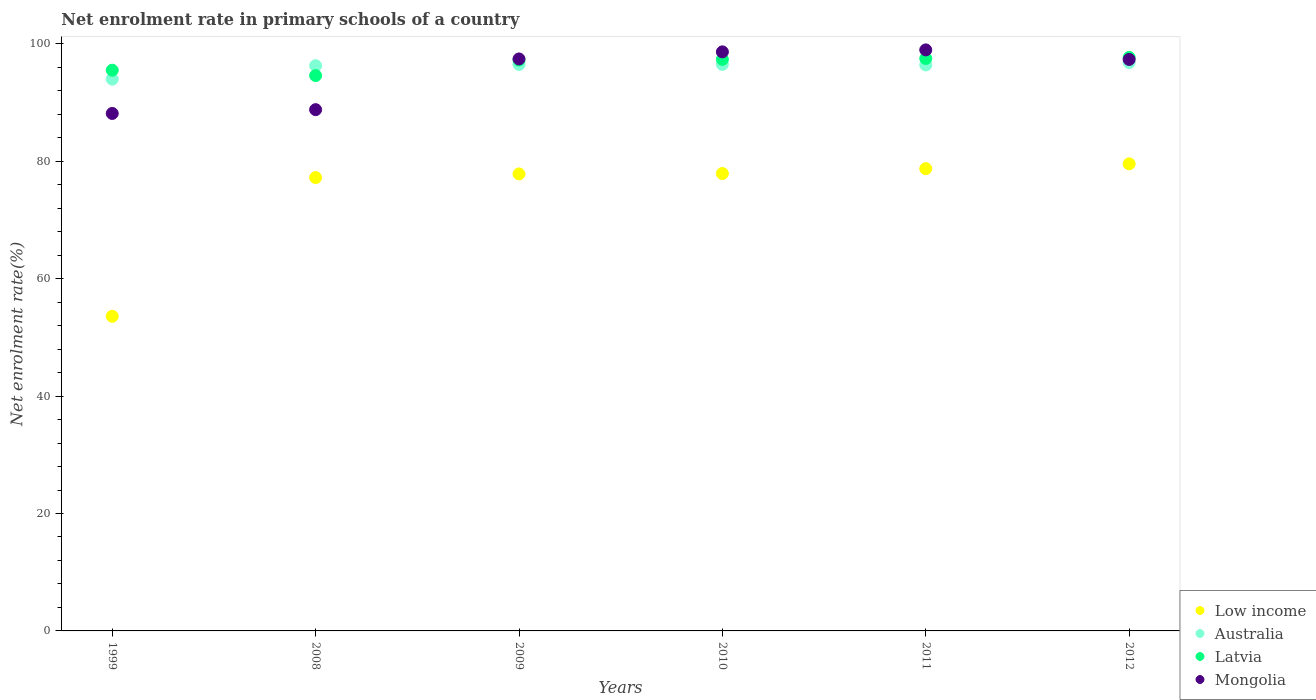How many different coloured dotlines are there?
Provide a succinct answer. 4. Is the number of dotlines equal to the number of legend labels?
Offer a very short reply. Yes. What is the net enrolment rate in primary schools in Latvia in 2010?
Provide a short and direct response. 97.35. Across all years, what is the maximum net enrolment rate in primary schools in Latvia?
Give a very brief answer. 97.68. Across all years, what is the minimum net enrolment rate in primary schools in Low income?
Your answer should be compact. 53.58. What is the total net enrolment rate in primary schools in Mongolia in the graph?
Give a very brief answer. 569.25. What is the difference between the net enrolment rate in primary schools in Mongolia in 2008 and that in 2011?
Keep it short and to the point. -10.18. What is the difference between the net enrolment rate in primary schools in Australia in 1999 and the net enrolment rate in primary schools in Low income in 2009?
Provide a short and direct response. 16.14. What is the average net enrolment rate in primary schools in Mongolia per year?
Ensure brevity in your answer.  94.87. In the year 2009, what is the difference between the net enrolment rate in primary schools in Low income and net enrolment rate in primary schools in Australia?
Offer a terse response. -18.65. What is the ratio of the net enrolment rate in primary schools in Mongolia in 2010 to that in 2011?
Provide a short and direct response. 1. Is the net enrolment rate in primary schools in Mongolia in 1999 less than that in 2009?
Provide a short and direct response. Yes. What is the difference between the highest and the second highest net enrolment rate in primary schools in Low income?
Provide a succinct answer. 0.82. What is the difference between the highest and the lowest net enrolment rate in primary schools in Australia?
Make the answer very short. 2.84. Is the sum of the net enrolment rate in primary schools in Low income in 1999 and 2011 greater than the maximum net enrolment rate in primary schools in Mongolia across all years?
Provide a succinct answer. Yes. Does the net enrolment rate in primary schools in Mongolia monotonically increase over the years?
Offer a terse response. No. Is the net enrolment rate in primary schools in Latvia strictly less than the net enrolment rate in primary schools in Low income over the years?
Make the answer very short. No. Are the values on the major ticks of Y-axis written in scientific E-notation?
Ensure brevity in your answer.  No. Does the graph contain grids?
Keep it short and to the point. No. How many legend labels are there?
Your response must be concise. 4. What is the title of the graph?
Your response must be concise. Net enrolment rate in primary schools of a country. What is the label or title of the Y-axis?
Provide a succinct answer. Net enrolment rate(%). What is the Net enrolment rate(%) in Low income in 1999?
Ensure brevity in your answer.  53.58. What is the Net enrolment rate(%) of Australia in 1999?
Offer a very short reply. 93.98. What is the Net enrolment rate(%) in Latvia in 1999?
Provide a succinct answer. 95.5. What is the Net enrolment rate(%) of Mongolia in 1999?
Your response must be concise. 88.13. What is the Net enrolment rate(%) in Low income in 2008?
Your answer should be compact. 77.21. What is the Net enrolment rate(%) of Australia in 2008?
Provide a succinct answer. 96.27. What is the Net enrolment rate(%) of Latvia in 2008?
Offer a terse response. 94.59. What is the Net enrolment rate(%) in Mongolia in 2008?
Give a very brief answer. 88.78. What is the Net enrolment rate(%) in Low income in 2009?
Ensure brevity in your answer.  77.84. What is the Net enrolment rate(%) of Australia in 2009?
Provide a short and direct response. 96.49. What is the Net enrolment rate(%) in Latvia in 2009?
Provide a short and direct response. 97.23. What is the Net enrolment rate(%) in Mongolia in 2009?
Provide a short and direct response. 97.42. What is the Net enrolment rate(%) of Low income in 2010?
Ensure brevity in your answer.  77.9. What is the Net enrolment rate(%) of Australia in 2010?
Your response must be concise. 96.49. What is the Net enrolment rate(%) of Latvia in 2010?
Your answer should be compact. 97.35. What is the Net enrolment rate(%) of Mongolia in 2010?
Your answer should be very brief. 98.62. What is the Net enrolment rate(%) in Low income in 2011?
Keep it short and to the point. 78.74. What is the Net enrolment rate(%) in Australia in 2011?
Provide a succinct answer. 96.4. What is the Net enrolment rate(%) of Latvia in 2011?
Your answer should be very brief. 97.49. What is the Net enrolment rate(%) in Mongolia in 2011?
Your answer should be very brief. 98.96. What is the Net enrolment rate(%) of Low income in 2012?
Make the answer very short. 79.55. What is the Net enrolment rate(%) in Australia in 2012?
Your answer should be compact. 96.82. What is the Net enrolment rate(%) of Latvia in 2012?
Provide a succinct answer. 97.68. What is the Net enrolment rate(%) of Mongolia in 2012?
Your answer should be very brief. 97.33. Across all years, what is the maximum Net enrolment rate(%) in Low income?
Provide a short and direct response. 79.55. Across all years, what is the maximum Net enrolment rate(%) in Australia?
Keep it short and to the point. 96.82. Across all years, what is the maximum Net enrolment rate(%) of Latvia?
Provide a succinct answer. 97.68. Across all years, what is the maximum Net enrolment rate(%) in Mongolia?
Provide a short and direct response. 98.96. Across all years, what is the minimum Net enrolment rate(%) in Low income?
Offer a very short reply. 53.58. Across all years, what is the minimum Net enrolment rate(%) in Australia?
Give a very brief answer. 93.98. Across all years, what is the minimum Net enrolment rate(%) of Latvia?
Provide a short and direct response. 94.59. Across all years, what is the minimum Net enrolment rate(%) of Mongolia?
Your answer should be very brief. 88.13. What is the total Net enrolment rate(%) in Low income in the graph?
Your answer should be very brief. 444.82. What is the total Net enrolment rate(%) of Australia in the graph?
Offer a terse response. 576.44. What is the total Net enrolment rate(%) of Latvia in the graph?
Your response must be concise. 579.83. What is the total Net enrolment rate(%) in Mongolia in the graph?
Ensure brevity in your answer.  569.25. What is the difference between the Net enrolment rate(%) of Low income in 1999 and that in 2008?
Offer a terse response. -23.63. What is the difference between the Net enrolment rate(%) in Australia in 1999 and that in 2008?
Make the answer very short. -2.29. What is the difference between the Net enrolment rate(%) in Latvia in 1999 and that in 2008?
Offer a very short reply. 0.91. What is the difference between the Net enrolment rate(%) of Mongolia in 1999 and that in 2008?
Provide a succinct answer. -0.65. What is the difference between the Net enrolment rate(%) in Low income in 1999 and that in 2009?
Offer a terse response. -24.25. What is the difference between the Net enrolment rate(%) in Australia in 1999 and that in 2009?
Your response must be concise. -2.51. What is the difference between the Net enrolment rate(%) in Latvia in 1999 and that in 2009?
Offer a terse response. -1.73. What is the difference between the Net enrolment rate(%) in Mongolia in 1999 and that in 2009?
Your answer should be compact. -9.28. What is the difference between the Net enrolment rate(%) of Low income in 1999 and that in 2010?
Provide a succinct answer. -24.32. What is the difference between the Net enrolment rate(%) of Australia in 1999 and that in 2010?
Provide a short and direct response. -2.51. What is the difference between the Net enrolment rate(%) in Latvia in 1999 and that in 2010?
Give a very brief answer. -1.85. What is the difference between the Net enrolment rate(%) in Mongolia in 1999 and that in 2010?
Provide a succinct answer. -10.49. What is the difference between the Net enrolment rate(%) of Low income in 1999 and that in 2011?
Keep it short and to the point. -25.15. What is the difference between the Net enrolment rate(%) of Australia in 1999 and that in 2011?
Keep it short and to the point. -2.42. What is the difference between the Net enrolment rate(%) in Latvia in 1999 and that in 2011?
Keep it short and to the point. -1.99. What is the difference between the Net enrolment rate(%) in Mongolia in 1999 and that in 2011?
Offer a terse response. -10.83. What is the difference between the Net enrolment rate(%) in Low income in 1999 and that in 2012?
Provide a short and direct response. -25.97. What is the difference between the Net enrolment rate(%) of Australia in 1999 and that in 2012?
Your answer should be compact. -2.84. What is the difference between the Net enrolment rate(%) of Latvia in 1999 and that in 2012?
Ensure brevity in your answer.  -2.18. What is the difference between the Net enrolment rate(%) of Mongolia in 1999 and that in 2012?
Make the answer very short. -9.2. What is the difference between the Net enrolment rate(%) of Low income in 2008 and that in 2009?
Your response must be concise. -0.63. What is the difference between the Net enrolment rate(%) in Australia in 2008 and that in 2009?
Your response must be concise. -0.21. What is the difference between the Net enrolment rate(%) of Latvia in 2008 and that in 2009?
Offer a terse response. -2.64. What is the difference between the Net enrolment rate(%) in Mongolia in 2008 and that in 2009?
Make the answer very short. -8.64. What is the difference between the Net enrolment rate(%) of Low income in 2008 and that in 2010?
Provide a succinct answer. -0.69. What is the difference between the Net enrolment rate(%) of Australia in 2008 and that in 2010?
Keep it short and to the point. -0.22. What is the difference between the Net enrolment rate(%) of Latvia in 2008 and that in 2010?
Offer a very short reply. -2.76. What is the difference between the Net enrolment rate(%) of Mongolia in 2008 and that in 2010?
Provide a succinct answer. -9.84. What is the difference between the Net enrolment rate(%) of Low income in 2008 and that in 2011?
Make the answer very short. -1.53. What is the difference between the Net enrolment rate(%) in Australia in 2008 and that in 2011?
Offer a very short reply. -0.12. What is the difference between the Net enrolment rate(%) in Latvia in 2008 and that in 2011?
Your answer should be very brief. -2.91. What is the difference between the Net enrolment rate(%) of Mongolia in 2008 and that in 2011?
Offer a very short reply. -10.18. What is the difference between the Net enrolment rate(%) of Low income in 2008 and that in 2012?
Ensure brevity in your answer.  -2.34. What is the difference between the Net enrolment rate(%) of Australia in 2008 and that in 2012?
Your answer should be compact. -0.55. What is the difference between the Net enrolment rate(%) of Latvia in 2008 and that in 2012?
Keep it short and to the point. -3.09. What is the difference between the Net enrolment rate(%) of Mongolia in 2008 and that in 2012?
Offer a very short reply. -8.55. What is the difference between the Net enrolment rate(%) in Low income in 2009 and that in 2010?
Ensure brevity in your answer.  -0.07. What is the difference between the Net enrolment rate(%) in Australia in 2009 and that in 2010?
Ensure brevity in your answer.  -0.01. What is the difference between the Net enrolment rate(%) of Latvia in 2009 and that in 2010?
Offer a very short reply. -0.12. What is the difference between the Net enrolment rate(%) of Mongolia in 2009 and that in 2010?
Provide a succinct answer. -1.2. What is the difference between the Net enrolment rate(%) of Low income in 2009 and that in 2011?
Offer a terse response. -0.9. What is the difference between the Net enrolment rate(%) in Australia in 2009 and that in 2011?
Provide a short and direct response. 0.09. What is the difference between the Net enrolment rate(%) of Latvia in 2009 and that in 2011?
Offer a terse response. -0.27. What is the difference between the Net enrolment rate(%) of Mongolia in 2009 and that in 2011?
Provide a succinct answer. -1.54. What is the difference between the Net enrolment rate(%) of Low income in 2009 and that in 2012?
Your answer should be compact. -1.72. What is the difference between the Net enrolment rate(%) in Australia in 2009 and that in 2012?
Your response must be concise. -0.34. What is the difference between the Net enrolment rate(%) in Latvia in 2009 and that in 2012?
Make the answer very short. -0.45. What is the difference between the Net enrolment rate(%) of Mongolia in 2009 and that in 2012?
Provide a short and direct response. 0.08. What is the difference between the Net enrolment rate(%) of Low income in 2010 and that in 2011?
Your answer should be compact. -0.83. What is the difference between the Net enrolment rate(%) of Australia in 2010 and that in 2011?
Give a very brief answer. 0.1. What is the difference between the Net enrolment rate(%) in Latvia in 2010 and that in 2011?
Keep it short and to the point. -0.15. What is the difference between the Net enrolment rate(%) of Mongolia in 2010 and that in 2011?
Your answer should be compact. -0.34. What is the difference between the Net enrolment rate(%) in Low income in 2010 and that in 2012?
Ensure brevity in your answer.  -1.65. What is the difference between the Net enrolment rate(%) of Australia in 2010 and that in 2012?
Provide a succinct answer. -0.33. What is the difference between the Net enrolment rate(%) in Latvia in 2010 and that in 2012?
Keep it short and to the point. -0.33. What is the difference between the Net enrolment rate(%) in Mongolia in 2010 and that in 2012?
Your answer should be very brief. 1.29. What is the difference between the Net enrolment rate(%) in Low income in 2011 and that in 2012?
Give a very brief answer. -0.82. What is the difference between the Net enrolment rate(%) in Australia in 2011 and that in 2012?
Your answer should be compact. -0.43. What is the difference between the Net enrolment rate(%) in Latvia in 2011 and that in 2012?
Provide a succinct answer. -0.18. What is the difference between the Net enrolment rate(%) in Mongolia in 2011 and that in 2012?
Provide a succinct answer. 1.63. What is the difference between the Net enrolment rate(%) in Low income in 1999 and the Net enrolment rate(%) in Australia in 2008?
Keep it short and to the point. -42.69. What is the difference between the Net enrolment rate(%) in Low income in 1999 and the Net enrolment rate(%) in Latvia in 2008?
Give a very brief answer. -41.01. What is the difference between the Net enrolment rate(%) of Low income in 1999 and the Net enrolment rate(%) of Mongolia in 2008?
Offer a terse response. -35.2. What is the difference between the Net enrolment rate(%) of Australia in 1999 and the Net enrolment rate(%) of Latvia in 2008?
Keep it short and to the point. -0.61. What is the difference between the Net enrolment rate(%) of Australia in 1999 and the Net enrolment rate(%) of Mongolia in 2008?
Offer a terse response. 5.2. What is the difference between the Net enrolment rate(%) of Latvia in 1999 and the Net enrolment rate(%) of Mongolia in 2008?
Provide a succinct answer. 6.72. What is the difference between the Net enrolment rate(%) in Low income in 1999 and the Net enrolment rate(%) in Australia in 2009?
Provide a short and direct response. -42.9. What is the difference between the Net enrolment rate(%) of Low income in 1999 and the Net enrolment rate(%) of Latvia in 2009?
Offer a very short reply. -43.64. What is the difference between the Net enrolment rate(%) in Low income in 1999 and the Net enrolment rate(%) in Mongolia in 2009?
Keep it short and to the point. -43.84. What is the difference between the Net enrolment rate(%) of Australia in 1999 and the Net enrolment rate(%) of Latvia in 2009?
Provide a succinct answer. -3.25. What is the difference between the Net enrolment rate(%) of Australia in 1999 and the Net enrolment rate(%) of Mongolia in 2009?
Ensure brevity in your answer.  -3.44. What is the difference between the Net enrolment rate(%) of Latvia in 1999 and the Net enrolment rate(%) of Mongolia in 2009?
Give a very brief answer. -1.92. What is the difference between the Net enrolment rate(%) of Low income in 1999 and the Net enrolment rate(%) of Australia in 2010?
Give a very brief answer. -42.91. What is the difference between the Net enrolment rate(%) in Low income in 1999 and the Net enrolment rate(%) in Latvia in 2010?
Ensure brevity in your answer.  -43.76. What is the difference between the Net enrolment rate(%) in Low income in 1999 and the Net enrolment rate(%) in Mongolia in 2010?
Offer a terse response. -45.04. What is the difference between the Net enrolment rate(%) of Australia in 1999 and the Net enrolment rate(%) of Latvia in 2010?
Your answer should be compact. -3.37. What is the difference between the Net enrolment rate(%) in Australia in 1999 and the Net enrolment rate(%) in Mongolia in 2010?
Keep it short and to the point. -4.65. What is the difference between the Net enrolment rate(%) of Latvia in 1999 and the Net enrolment rate(%) of Mongolia in 2010?
Keep it short and to the point. -3.12. What is the difference between the Net enrolment rate(%) of Low income in 1999 and the Net enrolment rate(%) of Australia in 2011?
Keep it short and to the point. -42.81. What is the difference between the Net enrolment rate(%) in Low income in 1999 and the Net enrolment rate(%) in Latvia in 2011?
Ensure brevity in your answer.  -43.91. What is the difference between the Net enrolment rate(%) of Low income in 1999 and the Net enrolment rate(%) of Mongolia in 2011?
Provide a short and direct response. -45.38. What is the difference between the Net enrolment rate(%) in Australia in 1999 and the Net enrolment rate(%) in Latvia in 2011?
Make the answer very short. -3.52. What is the difference between the Net enrolment rate(%) in Australia in 1999 and the Net enrolment rate(%) in Mongolia in 2011?
Your answer should be compact. -4.98. What is the difference between the Net enrolment rate(%) of Latvia in 1999 and the Net enrolment rate(%) of Mongolia in 2011?
Provide a succinct answer. -3.46. What is the difference between the Net enrolment rate(%) of Low income in 1999 and the Net enrolment rate(%) of Australia in 2012?
Your answer should be very brief. -43.24. What is the difference between the Net enrolment rate(%) in Low income in 1999 and the Net enrolment rate(%) in Latvia in 2012?
Provide a short and direct response. -44.1. What is the difference between the Net enrolment rate(%) of Low income in 1999 and the Net enrolment rate(%) of Mongolia in 2012?
Ensure brevity in your answer.  -43.75. What is the difference between the Net enrolment rate(%) of Australia in 1999 and the Net enrolment rate(%) of Latvia in 2012?
Provide a short and direct response. -3.7. What is the difference between the Net enrolment rate(%) of Australia in 1999 and the Net enrolment rate(%) of Mongolia in 2012?
Make the answer very short. -3.36. What is the difference between the Net enrolment rate(%) in Latvia in 1999 and the Net enrolment rate(%) in Mongolia in 2012?
Your response must be concise. -1.83. What is the difference between the Net enrolment rate(%) in Low income in 2008 and the Net enrolment rate(%) in Australia in 2009?
Provide a succinct answer. -19.28. What is the difference between the Net enrolment rate(%) in Low income in 2008 and the Net enrolment rate(%) in Latvia in 2009?
Your answer should be compact. -20.02. What is the difference between the Net enrolment rate(%) of Low income in 2008 and the Net enrolment rate(%) of Mongolia in 2009?
Ensure brevity in your answer.  -20.21. What is the difference between the Net enrolment rate(%) of Australia in 2008 and the Net enrolment rate(%) of Latvia in 2009?
Offer a very short reply. -0.95. What is the difference between the Net enrolment rate(%) in Australia in 2008 and the Net enrolment rate(%) in Mongolia in 2009?
Offer a terse response. -1.15. What is the difference between the Net enrolment rate(%) in Latvia in 2008 and the Net enrolment rate(%) in Mongolia in 2009?
Offer a very short reply. -2.83. What is the difference between the Net enrolment rate(%) of Low income in 2008 and the Net enrolment rate(%) of Australia in 2010?
Your answer should be compact. -19.28. What is the difference between the Net enrolment rate(%) in Low income in 2008 and the Net enrolment rate(%) in Latvia in 2010?
Provide a succinct answer. -20.14. What is the difference between the Net enrolment rate(%) in Low income in 2008 and the Net enrolment rate(%) in Mongolia in 2010?
Make the answer very short. -21.41. What is the difference between the Net enrolment rate(%) in Australia in 2008 and the Net enrolment rate(%) in Latvia in 2010?
Your answer should be very brief. -1.08. What is the difference between the Net enrolment rate(%) of Australia in 2008 and the Net enrolment rate(%) of Mongolia in 2010?
Ensure brevity in your answer.  -2.35. What is the difference between the Net enrolment rate(%) in Latvia in 2008 and the Net enrolment rate(%) in Mongolia in 2010?
Your answer should be very brief. -4.03. What is the difference between the Net enrolment rate(%) of Low income in 2008 and the Net enrolment rate(%) of Australia in 2011?
Your response must be concise. -19.19. What is the difference between the Net enrolment rate(%) in Low income in 2008 and the Net enrolment rate(%) in Latvia in 2011?
Your response must be concise. -20.28. What is the difference between the Net enrolment rate(%) in Low income in 2008 and the Net enrolment rate(%) in Mongolia in 2011?
Provide a succinct answer. -21.75. What is the difference between the Net enrolment rate(%) in Australia in 2008 and the Net enrolment rate(%) in Latvia in 2011?
Give a very brief answer. -1.22. What is the difference between the Net enrolment rate(%) of Australia in 2008 and the Net enrolment rate(%) of Mongolia in 2011?
Make the answer very short. -2.69. What is the difference between the Net enrolment rate(%) of Latvia in 2008 and the Net enrolment rate(%) of Mongolia in 2011?
Give a very brief answer. -4.37. What is the difference between the Net enrolment rate(%) in Low income in 2008 and the Net enrolment rate(%) in Australia in 2012?
Your response must be concise. -19.61. What is the difference between the Net enrolment rate(%) of Low income in 2008 and the Net enrolment rate(%) of Latvia in 2012?
Provide a short and direct response. -20.47. What is the difference between the Net enrolment rate(%) of Low income in 2008 and the Net enrolment rate(%) of Mongolia in 2012?
Provide a succinct answer. -20.12. What is the difference between the Net enrolment rate(%) in Australia in 2008 and the Net enrolment rate(%) in Latvia in 2012?
Offer a very short reply. -1.41. What is the difference between the Net enrolment rate(%) of Australia in 2008 and the Net enrolment rate(%) of Mongolia in 2012?
Give a very brief answer. -1.06. What is the difference between the Net enrolment rate(%) in Latvia in 2008 and the Net enrolment rate(%) in Mongolia in 2012?
Give a very brief answer. -2.75. What is the difference between the Net enrolment rate(%) in Low income in 2009 and the Net enrolment rate(%) in Australia in 2010?
Keep it short and to the point. -18.66. What is the difference between the Net enrolment rate(%) in Low income in 2009 and the Net enrolment rate(%) in Latvia in 2010?
Make the answer very short. -19.51. What is the difference between the Net enrolment rate(%) of Low income in 2009 and the Net enrolment rate(%) of Mongolia in 2010?
Offer a terse response. -20.79. What is the difference between the Net enrolment rate(%) of Australia in 2009 and the Net enrolment rate(%) of Latvia in 2010?
Offer a terse response. -0.86. What is the difference between the Net enrolment rate(%) in Australia in 2009 and the Net enrolment rate(%) in Mongolia in 2010?
Provide a short and direct response. -2.14. What is the difference between the Net enrolment rate(%) of Latvia in 2009 and the Net enrolment rate(%) of Mongolia in 2010?
Keep it short and to the point. -1.4. What is the difference between the Net enrolment rate(%) of Low income in 2009 and the Net enrolment rate(%) of Australia in 2011?
Give a very brief answer. -18.56. What is the difference between the Net enrolment rate(%) of Low income in 2009 and the Net enrolment rate(%) of Latvia in 2011?
Ensure brevity in your answer.  -19.66. What is the difference between the Net enrolment rate(%) in Low income in 2009 and the Net enrolment rate(%) in Mongolia in 2011?
Offer a terse response. -21.12. What is the difference between the Net enrolment rate(%) in Australia in 2009 and the Net enrolment rate(%) in Latvia in 2011?
Offer a terse response. -1.01. What is the difference between the Net enrolment rate(%) of Australia in 2009 and the Net enrolment rate(%) of Mongolia in 2011?
Your answer should be very brief. -2.47. What is the difference between the Net enrolment rate(%) in Latvia in 2009 and the Net enrolment rate(%) in Mongolia in 2011?
Ensure brevity in your answer.  -1.73. What is the difference between the Net enrolment rate(%) of Low income in 2009 and the Net enrolment rate(%) of Australia in 2012?
Your answer should be very brief. -18.99. What is the difference between the Net enrolment rate(%) in Low income in 2009 and the Net enrolment rate(%) in Latvia in 2012?
Keep it short and to the point. -19.84. What is the difference between the Net enrolment rate(%) in Low income in 2009 and the Net enrolment rate(%) in Mongolia in 2012?
Provide a succinct answer. -19.5. What is the difference between the Net enrolment rate(%) in Australia in 2009 and the Net enrolment rate(%) in Latvia in 2012?
Your response must be concise. -1.19. What is the difference between the Net enrolment rate(%) of Australia in 2009 and the Net enrolment rate(%) of Mongolia in 2012?
Keep it short and to the point. -0.85. What is the difference between the Net enrolment rate(%) in Latvia in 2009 and the Net enrolment rate(%) in Mongolia in 2012?
Make the answer very short. -0.11. What is the difference between the Net enrolment rate(%) in Low income in 2010 and the Net enrolment rate(%) in Australia in 2011?
Offer a very short reply. -18.49. What is the difference between the Net enrolment rate(%) of Low income in 2010 and the Net enrolment rate(%) of Latvia in 2011?
Your answer should be very brief. -19.59. What is the difference between the Net enrolment rate(%) of Low income in 2010 and the Net enrolment rate(%) of Mongolia in 2011?
Give a very brief answer. -21.06. What is the difference between the Net enrolment rate(%) in Australia in 2010 and the Net enrolment rate(%) in Latvia in 2011?
Ensure brevity in your answer.  -1. What is the difference between the Net enrolment rate(%) of Australia in 2010 and the Net enrolment rate(%) of Mongolia in 2011?
Keep it short and to the point. -2.47. What is the difference between the Net enrolment rate(%) of Latvia in 2010 and the Net enrolment rate(%) of Mongolia in 2011?
Give a very brief answer. -1.61. What is the difference between the Net enrolment rate(%) in Low income in 2010 and the Net enrolment rate(%) in Australia in 2012?
Provide a succinct answer. -18.92. What is the difference between the Net enrolment rate(%) of Low income in 2010 and the Net enrolment rate(%) of Latvia in 2012?
Offer a very short reply. -19.77. What is the difference between the Net enrolment rate(%) in Low income in 2010 and the Net enrolment rate(%) in Mongolia in 2012?
Offer a terse response. -19.43. What is the difference between the Net enrolment rate(%) of Australia in 2010 and the Net enrolment rate(%) of Latvia in 2012?
Offer a terse response. -1.19. What is the difference between the Net enrolment rate(%) of Australia in 2010 and the Net enrolment rate(%) of Mongolia in 2012?
Offer a terse response. -0.84. What is the difference between the Net enrolment rate(%) in Latvia in 2010 and the Net enrolment rate(%) in Mongolia in 2012?
Your answer should be very brief. 0.01. What is the difference between the Net enrolment rate(%) of Low income in 2011 and the Net enrolment rate(%) of Australia in 2012?
Give a very brief answer. -18.09. What is the difference between the Net enrolment rate(%) in Low income in 2011 and the Net enrolment rate(%) in Latvia in 2012?
Make the answer very short. -18.94. What is the difference between the Net enrolment rate(%) in Low income in 2011 and the Net enrolment rate(%) in Mongolia in 2012?
Ensure brevity in your answer.  -18.6. What is the difference between the Net enrolment rate(%) of Australia in 2011 and the Net enrolment rate(%) of Latvia in 2012?
Give a very brief answer. -1.28. What is the difference between the Net enrolment rate(%) in Australia in 2011 and the Net enrolment rate(%) in Mongolia in 2012?
Offer a terse response. -0.94. What is the difference between the Net enrolment rate(%) in Latvia in 2011 and the Net enrolment rate(%) in Mongolia in 2012?
Your answer should be very brief. 0.16. What is the average Net enrolment rate(%) in Low income per year?
Give a very brief answer. 74.14. What is the average Net enrolment rate(%) in Australia per year?
Your answer should be very brief. 96.07. What is the average Net enrolment rate(%) of Latvia per year?
Give a very brief answer. 96.64. What is the average Net enrolment rate(%) in Mongolia per year?
Make the answer very short. 94.87. In the year 1999, what is the difference between the Net enrolment rate(%) of Low income and Net enrolment rate(%) of Australia?
Your answer should be compact. -40.4. In the year 1999, what is the difference between the Net enrolment rate(%) in Low income and Net enrolment rate(%) in Latvia?
Your answer should be very brief. -41.92. In the year 1999, what is the difference between the Net enrolment rate(%) of Low income and Net enrolment rate(%) of Mongolia?
Provide a succinct answer. -34.55. In the year 1999, what is the difference between the Net enrolment rate(%) of Australia and Net enrolment rate(%) of Latvia?
Offer a very short reply. -1.52. In the year 1999, what is the difference between the Net enrolment rate(%) of Australia and Net enrolment rate(%) of Mongolia?
Your answer should be very brief. 5.84. In the year 1999, what is the difference between the Net enrolment rate(%) of Latvia and Net enrolment rate(%) of Mongolia?
Provide a succinct answer. 7.37. In the year 2008, what is the difference between the Net enrolment rate(%) in Low income and Net enrolment rate(%) in Australia?
Your answer should be compact. -19.06. In the year 2008, what is the difference between the Net enrolment rate(%) in Low income and Net enrolment rate(%) in Latvia?
Your answer should be compact. -17.38. In the year 2008, what is the difference between the Net enrolment rate(%) of Low income and Net enrolment rate(%) of Mongolia?
Make the answer very short. -11.57. In the year 2008, what is the difference between the Net enrolment rate(%) in Australia and Net enrolment rate(%) in Latvia?
Give a very brief answer. 1.68. In the year 2008, what is the difference between the Net enrolment rate(%) in Australia and Net enrolment rate(%) in Mongolia?
Offer a terse response. 7.49. In the year 2008, what is the difference between the Net enrolment rate(%) of Latvia and Net enrolment rate(%) of Mongolia?
Your answer should be very brief. 5.81. In the year 2009, what is the difference between the Net enrolment rate(%) in Low income and Net enrolment rate(%) in Australia?
Your answer should be very brief. -18.65. In the year 2009, what is the difference between the Net enrolment rate(%) in Low income and Net enrolment rate(%) in Latvia?
Provide a succinct answer. -19.39. In the year 2009, what is the difference between the Net enrolment rate(%) in Low income and Net enrolment rate(%) in Mongolia?
Provide a short and direct response. -19.58. In the year 2009, what is the difference between the Net enrolment rate(%) of Australia and Net enrolment rate(%) of Latvia?
Your response must be concise. -0.74. In the year 2009, what is the difference between the Net enrolment rate(%) of Australia and Net enrolment rate(%) of Mongolia?
Give a very brief answer. -0.93. In the year 2009, what is the difference between the Net enrolment rate(%) in Latvia and Net enrolment rate(%) in Mongolia?
Your response must be concise. -0.19. In the year 2010, what is the difference between the Net enrolment rate(%) of Low income and Net enrolment rate(%) of Australia?
Give a very brief answer. -18.59. In the year 2010, what is the difference between the Net enrolment rate(%) in Low income and Net enrolment rate(%) in Latvia?
Provide a succinct answer. -19.44. In the year 2010, what is the difference between the Net enrolment rate(%) of Low income and Net enrolment rate(%) of Mongolia?
Your response must be concise. -20.72. In the year 2010, what is the difference between the Net enrolment rate(%) of Australia and Net enrolment rate(%) of Latvia?
Your answer should be compact. -0.86. In the year 2010, what is the difference between the Net enrolment rate(%) in Australia and Net enrolment rate(%) in Mongolia?
Provide a short and direct response. -2.13. In the year 2010, what is the difference between the Net enrolment rate(%) in Latvia and Net enrolment rate(%) in Mongolia?
Give a very brief answer. -1.28. In the year 2011, what is the difference between the Net enrolment rate(%) in Low income and Net enrolment rate(%) in Australia?
Offer a terse response. -17.66. In the year 2011, what is the difference between the Net enrolment rate(%) of Low income and Net enrolment rate(%) of Latvia?
Your answer should be very brief. -18.76. In the year 2011, what is the difference between the Net enrolment rate(%) in Low income and Net enrolment rate(%) in Mongolia?
Your answer should be very brief. -20.22. In the year 2011, what is the difference between the Net enrolment rate(%) of Australia and Net enrolment rate(%) of Latvia?
Keep it short and to the point. -1.1. In the year 2011, what is the difference between the Net enrolment rate(%) of Australia and Net enrolment rate(%) of Mongolia?
Keep it short and to the point. -2.56. In the year 2011, what is the difference between the Net enrolment rate(%) of Latvia and Net enrolment rate(%) of Mongolia?
Your answer should be very brief. -1.46. In the year 2012, what is the difference between the Net enrolment rate(%) in Low income and Net enrolment rate(%) in Australia?
Your answer should be compact. -17.27. In the year 2012, what is the difference between the Net enrolment rate(%) of Low income and Net enrolment rate(%) of Latvia?
Offer a very short reply. -18.13. In the year 2012, what is the difference between the Net enrolment rate(%) in Low income and Net enrolment rate(%) in Mongolia?
Make the answer very short. -17.78. In the year 2012, what is the difference between the Net enrolment rate(%) of Australia and Net enrolment rate(%) of Latvia?
Give a very brief answer. -0.86. In the year 2012, what is the difference between the Net enrolment rate(%) of Australia and Net enrolment rate(%) of Mongolia?
Your answer should be very brief. -0.51. In the year 2012, what is the difference between the Net enrolment rate(%) in Latvia and Net enrolment rate(%) in Mongolia?
Provide a succinct answer. 0.34. What is the ratio of the Net enrolment rate(%) in Low income in 1999 to that in 2008?
Keep it short and to the point. 0.69. What is the ratio of the Net enrolment rate(%) in Australia in 1999 to that in 2008?
Provide a short and direct response. 0.98. What is the ratio of the Net enrolment rate(%) of Latvia in 1999 to that in 2008?
Your answer should be very brief. 1.01. What is the ratio of the Net enrolment rate(%) in Low income in 1999 to that in 2009?
Provide a short and direct response. 0.69. What is the ratio of the Net enrolment rate(%) in Australia in 1999 to that in 2009?
Make the answer very short. 0.97. What is the ratio of the Net enrolment rate(%) of Latvia in 1999 to that in 2009?
Make the answer very short. 0.98. What is the ratio of the Net enrolment rate(%) in Mongolia in 1999 to that in 2009?
Make the answer very short. 0.9. What is the ratio of the Net enrolment rate(%) in Low income in 1999 to that in 2010?
Provide a short and direct response. 0.69. What is the ratio of the Net enrolment rate(%) of Australia in 1999 to that in 2010?
Give a very brief answer. 0.97. What is the ratio of the Net enrolment rate(%) in Mongolia in 1999 to that in 2010?
Offer a terse response. 0.89. What is the ratio of the Net enrolment rate(%) of Low income in 1999 to that in 2011?
Provide a succinct answer. 0.68. What is the ratio of the Net enrolment rate(%) in Australia in 1999 to that in 2011?
Your response must be concise. 0.97. What is the ratio of the Net enrolment rate(%) of Latvia in 1999 to that in 2011?
Provide a succinct answer. 0.98. What is the ratio of the Net enrolment rate(%) of Mongolia in 1999 to that in 2011?
Your response must be concise. 0.89. What is the ratio of the Net enrolment rate(%) of Low income in 1999 to that in 2012?
Your answer should be very brief. 0.67. What is the ratio of the Net enrolment rate(%) in Australia in 1999 to that in 2012?
Your answer should be very brief. 0.97. What is the ratio of the Net enrolment rate(%) of Latvia in 1999 to that in 2012?
Your response must be concise. 0.98. What is the ratio of the Net enrolment rate(%) of Mongolia in 1999 to that in 2012?
Your answer should be very brief. 0.91. What is the ratio of the Net enrolment rate(%) of Low income in 2008 to that in 2009?
Offer a terse response. 0.99. What is the ratio of the Net enrolment rate(%) of Australia in 2008 to that in 2009?
Your answer should be compact. 1. What is the ratio of the Net enrolment rate(%) of Latvia in 2008 to that in 2009?
Offer a very short reply. 0.97. What is the ratio of the Net enrolment rate(%) of Mongolia in 2008 to that in 2009?
Provide a short and direct response. 0.91. What is the ratio of the Net enrolment rate(%) of Australia in 2008 to that in 2010?
Provide a short and direct response. 1. What is the ratio of the Net enrolment rate(%) in Latvia in 2008 to that in 2010?
Ensure brevity in your answer.  0.97. What is the ratio of the Net enrolment rate(%) in Mongolia in 2008 to that in 2010?
Give a very brief answer. 0.9. What is the ratio of the Net enrolment rate(%) of Low income in 2008 to that in 2011?
Give a very brief answer. 0.98. What is the ratio of the Net enrolment rate(%) of Australia in 2008 to that in 2011?
Give a very brief answer. 1. What is the ratio of the Net enrolment rate(%) of Latvia in 2008 to that in 2011?
Provide a short and direct response. 0.97. What is the ratio of the Net enrolment rate(%) in Mongolia in 2008 to that in 2011?
Provide a short and direct response. 0.9. What is the ratio of the Net enrolment rate(%) in Low income in 2008 to that in 2012?
Your answer should be very brief. 0.97. What is the ratio of the Net enrolment rate(%) in Latvia in 2008 to that in 2012?
Provide a succinct answer. 0.97. What is the ratio of the Net enrolment rate(%) of Mongolia in 2008 to that in 2012?
Offer a very short reply. 0.91. What is the ratio of the Net enrolment rate(%) of Low income in 2009 to that in 2010?
Offer a very short reply. 1. What is the ratio of the Net enrolment rate(%) in Australia in 2009 to that in 2010?
Offer a terse response. 1. What is the ratio of the Net enrolment rate(%) in Latvia in 2009 to that in 2010?
Offer a terse response. 1. What is the ratio of the Net enrolment rate(%) in Mongolia in 2009 to that in 2011?
Your answer should be compact. 0.98. What is the ratio of the Net enrolment rate(%) in Low income in 2009 to that in 2012?
Your answer should be compact. 0.98. What is the ratio of the Net enrolment rate(%) in Mongolia in 2009 to that in 2012?
Offer a terse response. 1. What is the ratio of the Net enrolment rate(%) in Low income in 2010 to that in 2011?
Your answer should be very brief. 0.99. What is the ratio of the Net enrolment rate(%) of Australia in 2010 to that in 2011?
Give a very brief answer. 1. What is the ratio of the Net enrolment rate(%) of Low income in 2010 to that in 2012?
Keep it short and to the point. 0.98. What is the ratio of the Net enrolment rate(%) in Australia in 2010 to that in 2012?
Provide a short and direct response. 1. What is the ratio of the Net enrolment rate(%) in Mongolia in 2010 to that in 2012?
Offer a terse response. 1.01. What is the ratio of the Net enrolment rate(%) of Mongolia in 2011 to that in 2012?
Your answer should be compact. 1.02. What is the difference between the highest and the second highest Net enrolment rate(%) of Low income?
Give a very brief answer. 0.82. What is the difference between the highest and the second highest Net enrolment rate(%) of Australia?
Your response must be concise. 0.33. What is the difference between the highest and the second highest Net enrolment rate(%) of Latvia?
Give a very brief answer. 0.18. What is the difference between the highest and the second highest Net enrolment rate(%) in Mongolia?
Ensure brevity in your answer.  0.34. What is the difference between the highest and the lowest Net enrolment rate(%) in Low income?
Make the answer very short. 25.97. What is the difference between the highest and the lowest Net enrolment rate(%) of Australia?
Offer a very short reply. 2.84. What is the difference between the highest and the lowest Net enrolment rate(%) in Latvia?
Keep it short and to the point. 3.09. What is the difference between the highest and the lowest Net enrolment rate(%) of Mongolia?
Ensure brevity in your answer.  10.83. 